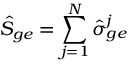Convert formula to latex. <formula><loc_0><loc_0><loc_500><loc_500>\hat { S } _ { g e } = \sum _ { j = 1 } ^ { N } \hat { \sigma } _ { g e } ^ { j }</formula> 